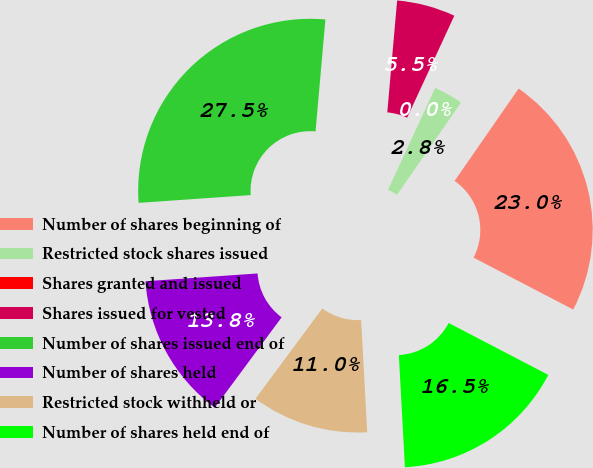<chart> <loc_0><loc_0><loc_500><loc_500><pie_chart><fcel>Number of shares beginning of<fcel>Restricted stock shares issued<fcel>Shares granted and issued<fcel>Shares issued for vested<fcel>Number of shares issued end of<fcel>Number of shares held<fcel>Restricted stock withheld or<fcel>Number of shares held end of<nl><fcel>22.99%<fcel>2.75%<fcel>0.0%<fcel>5.5%<fcel>27.5%<fcel>13.75%<fcel>11.0%<fcel>16.5%<nl></chart> 